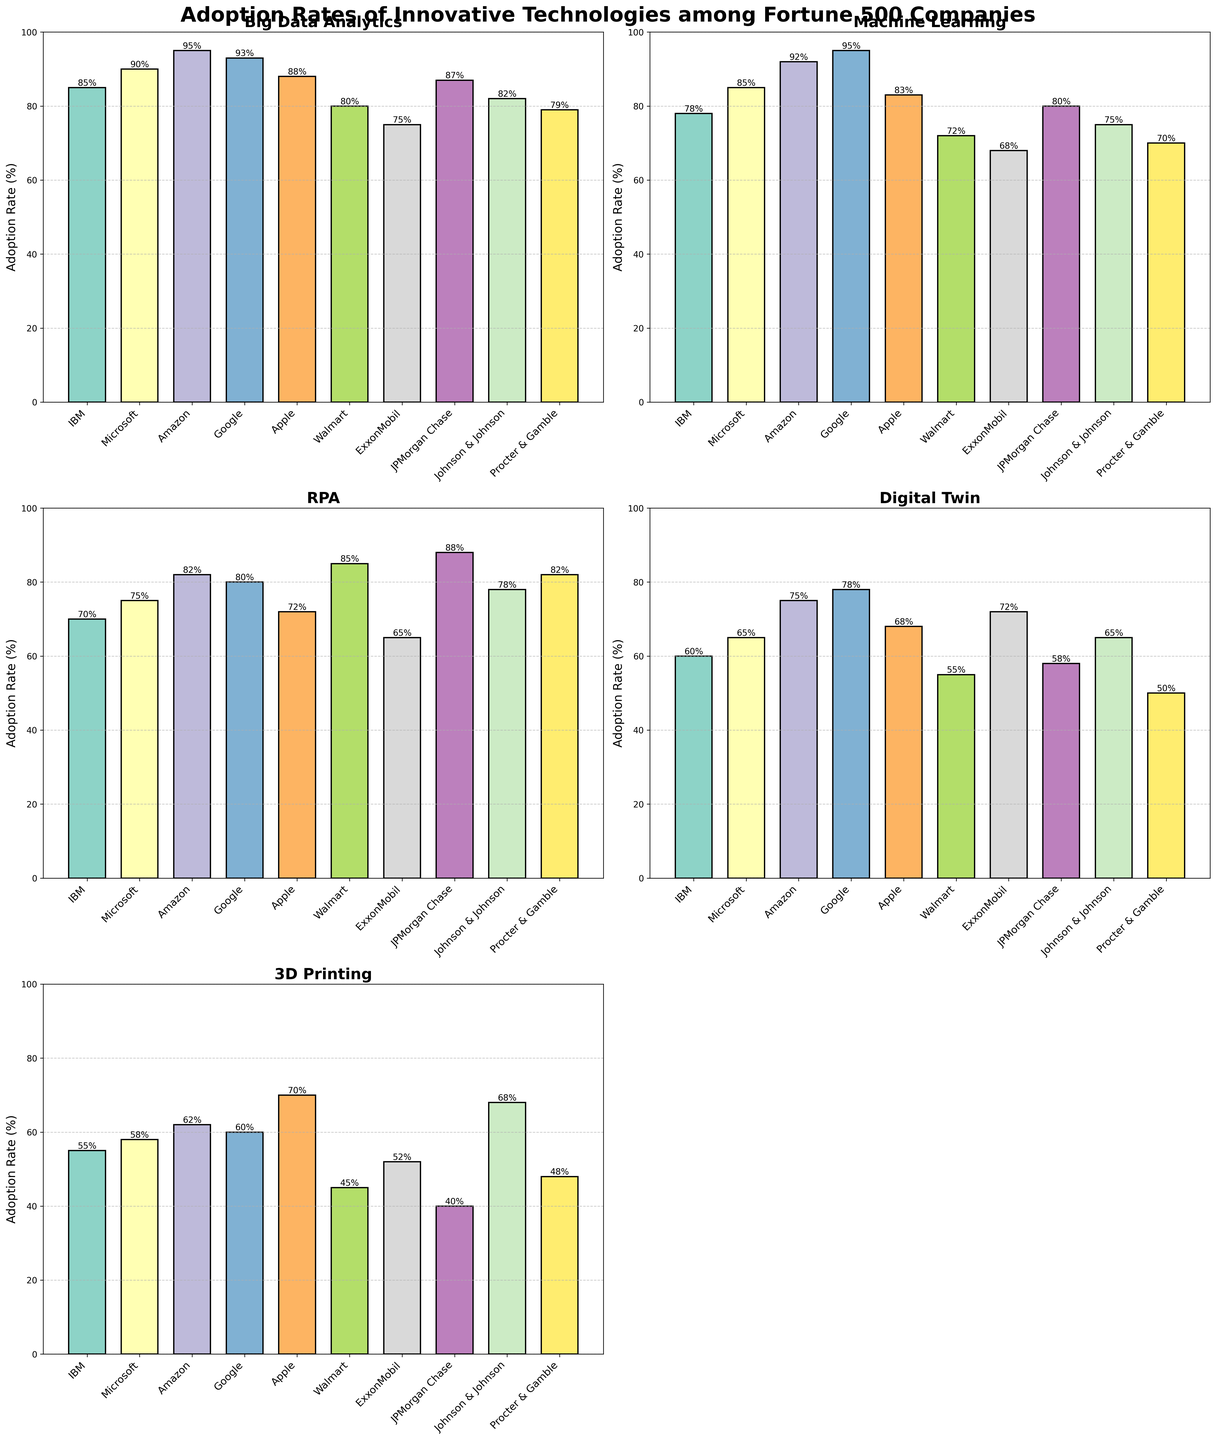What is the title of the figure? The title is usually located at the top of the figure and is displayed prominently.
Answer: Adoption Rates of Innovative Technologies among Fortune 500 Companies How many subplots are present in the figure? To determine the number of subplots, count the individual charts within the figure. There are 5 subplots for each technology.
Answer: 5 Which technology has the highest adoption rate by Amazon? Find the bar representing Amazon in each subplot and identify the one with the highest value. Amazon has the highest adoption rate for Big Data Analytics at 95%.
Answer: Big Data Analytics Which company has the lowest adoption rate for Digital Twin? Check the Digital Twin subplot, look for the lowest bar, and identify the corresponding company. The lowest adoption rate for Digital Twin is by Procter & Gamble with 50%.
Answer: Procter & Gamble Compare the adoption rates of Machine Learning and 3D Printing for Google. Which one is higher and by how much? First, locate Google in both the Machine Learning and 3D Printing subplots. Google's adoption rate for Machine Learning is 95%, and for 3D Printing, it is 60%. The difference is 95% - 60% = 35%.
Answer: Machine Learning by 35% What is the average adoption rate for RPA across all companies? Sum all the RPA adoption rates and divide by the number of companies. (70 + 75 + 82 + 80 + 72 + 85 + 65 + 88 + 78 + 82) / 10 = 77.7%
Answer: 77.7% Which technology has the most uniform adoption rates among the companies? Examine the width of the bars for each technology. Machine Learning has relatively uniform adoption rates across companies ranging from 68% to 95%.
Answer: Machine Learning What is the median adoption rate for 3D Printing across all companies? Arrange the 3D Printing adoption rates in numerical order and find the middle value. The sorted rates are [40, 45, 48, 52, 55, 58, 60, 62, 68, 70], so the median is the average of the 5th and 6th values: (55+58)/2 = 56.5%.
Answer: 56.5% Which company shows the largest difference in adoption rates between Big Data Analytics and Digital Twin? Calculate the difference for each company and find the maximum. For Walmart: BDA = 80%, DT = 55%, difference: 80 - 55 = 25%. The largest difference is by Walmart.
Answer: Walmart 